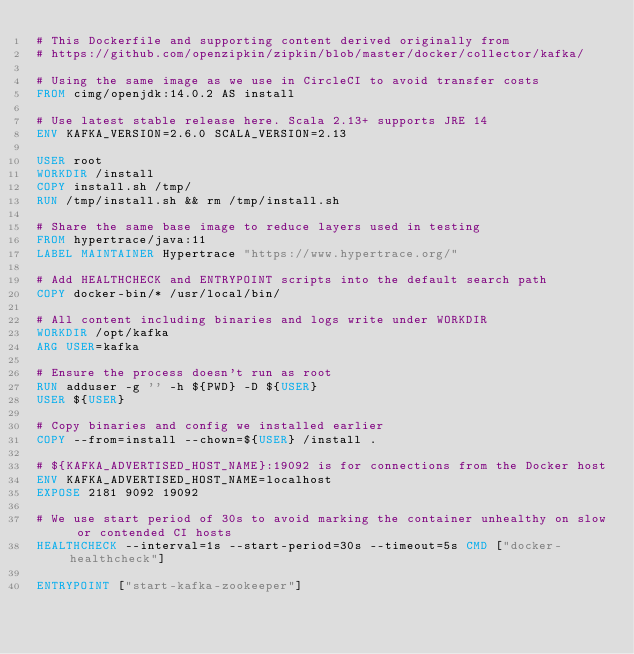<code> <loc_0><loc_0><loc_500><loc_500><_Dockerfile_># This Dockerfile and supporting content derived originally from
# https://github.com/openzipkin/zipkin/blob/master/docker/collector/kafka/

# Using the same image as we use in CircleCI to avoid transfer costs
FROM cimg/openjdk:14.0.2 AS install

# Use latest stable release here. Scala 2.13+ supports JRE 14
ENV KAFKA_VERSION=2.6.0 SCALA_VERSION=2.13

USER root
WORKDIR /install
COPY install.sh /tmp/
RUN /tmp/install.sh && rm /tmp/install.sh

# Share the same base image to reduce layers used in testing
FROM hypertrace/java:11
LABEL MAINTAINER Hypertrace "https://www.hypertrace.org/"

# Add HEALTHCHECK and ENTRYPOINT scripts into the default search path
COPY docker-bin/* /usr/local/bin/

# All content including binaries and logs write under WORKDIR
WORKDIR /opt/kafka
ARG USER=kafka

# Ensure the process doesn't run as root
RUN adduser -g '' -h ${PWD} -D ${USER}
USER ${USER}

# Copy binaries and config we installed earlier
COPY --from=install --chown=${USER} /install .

# ${KAFKA_ADVERTISED_HOST_NAME}:19092 is for connections from the Docker host
ENV KAFKA_ADVERTISED_HOST_NAME=localhost
EXPOSE 2181 9092 19092

# We use start period of 30s to avoid marking the container unhealthy on slow or contended CI hosts
HEALTHCHECK --interval=1s --start-period=30s --timeout=5s CMD ["docker-healthcheck"]

ENTRYPOINT ["start-kafka-zookeeper"]
</code> 